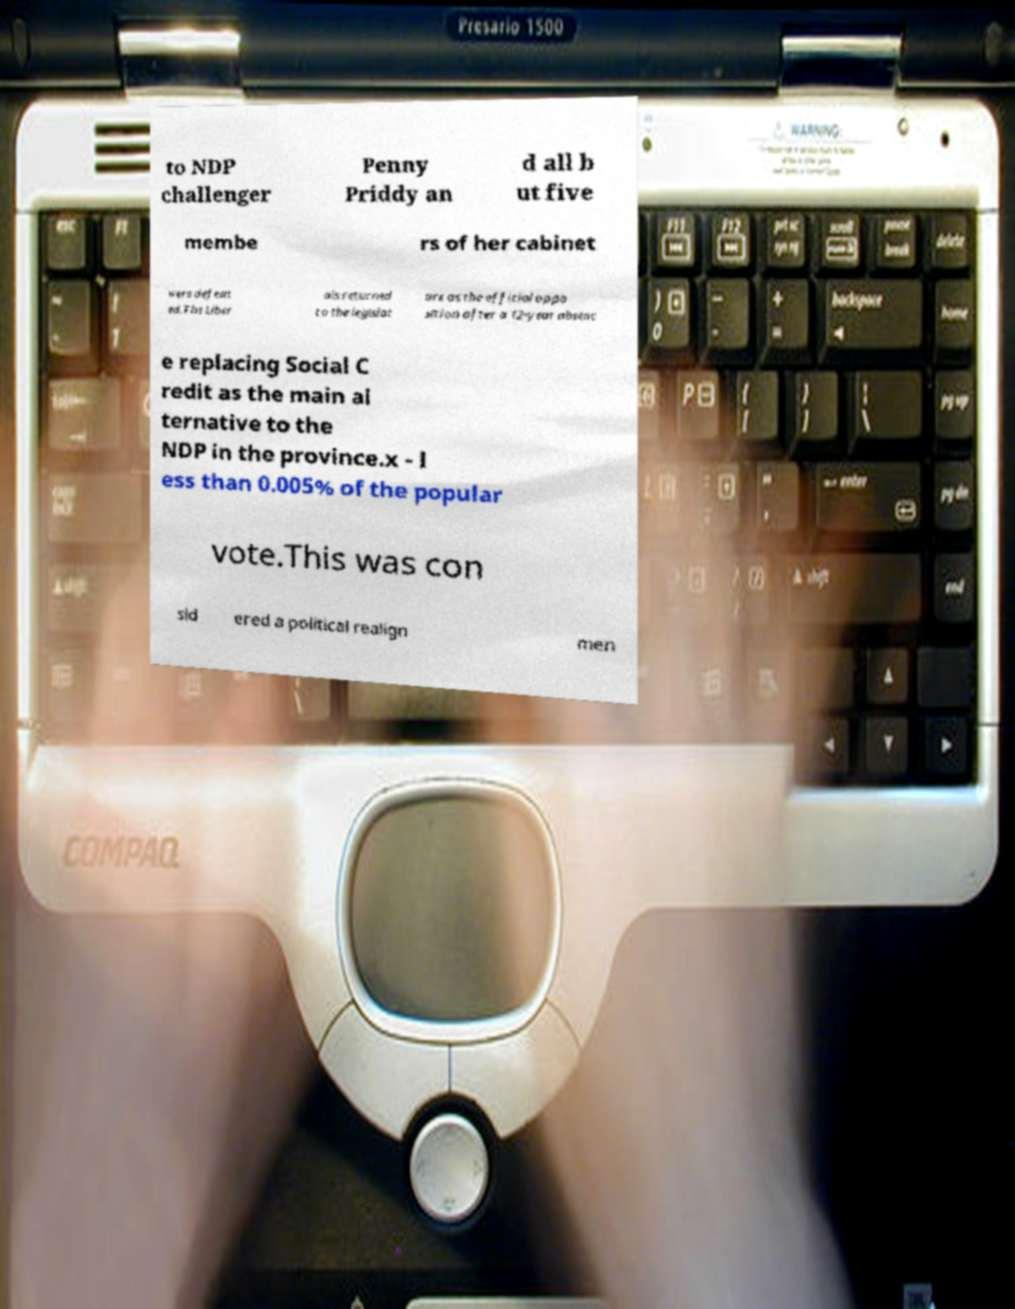Can you accurately transcribe the text from the provided image for me? to NDP challenger Penny Priddy an d all b ut five membe rs of her cabinet were defeat ed.The Liber als returned to the legislat ure as the official oppo sition after a 12-year absenc e replacing Social C redit as the main al ternative to the NDP in the province.x - l ess than 0.005% of the popular vote.This was con sid ered a political realign men 